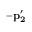<formula> <loc_0><loc_0><loc_500><loc_500>{ - p _ { 2 } ^ { \prime } }</formula> 